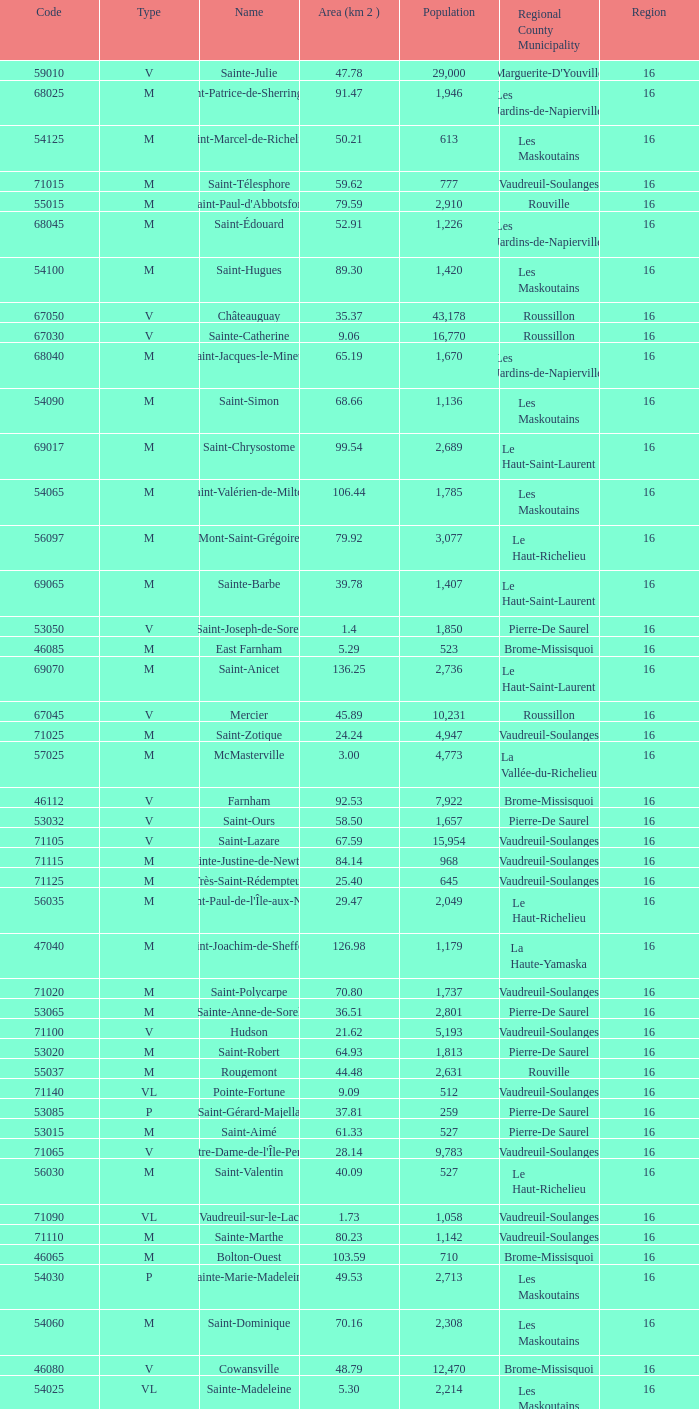Cowansville has less than 16 regions and is a Brome-Missisquoi Municipality, what is their population? None. 